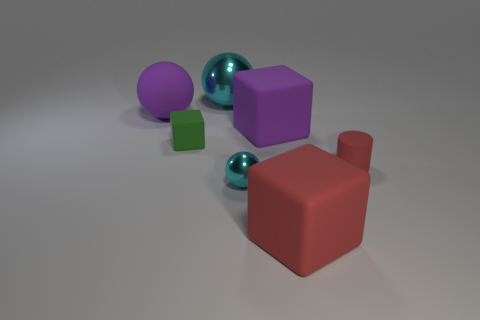What is the shape of the thing that is the same color as the cylinder?
Provide a short and direct response. Cube. Do the large block in front of the small block and the matte cylinder have the same color?
Your answer should be compact. Yes. There is a cyan metallic ball in front of the purple matte block; is its size the same as the red object to the right of the red cube?
Make the answer very short. Yes. What color is the shiny thing that is in front of the purple thing to the right of the small cyan object?
Offer a very short reply. Cyan. There is a red cylinder that is the same size as the green rubber thing; what material is it?
Offer a terse response. Rubber. How many metallic objects are either blue objects or large objects?
Offer a terse response. 1. There is a object that is both behind the purple rubber block and on the left side of the big cyan thing; what color is it?
Provide a succinct answer. Purple. What number of big spheres are in front of the large red cube?
Your answer should be very brief. 0. What material is the small red cylinder?
Your response must be concise. Rubber. There is a large sphere behind the large rubber object on the left side of the purple matte object that is right of the large cyan shiny ball; what color is it?
Offer a terse response. Cyan. 